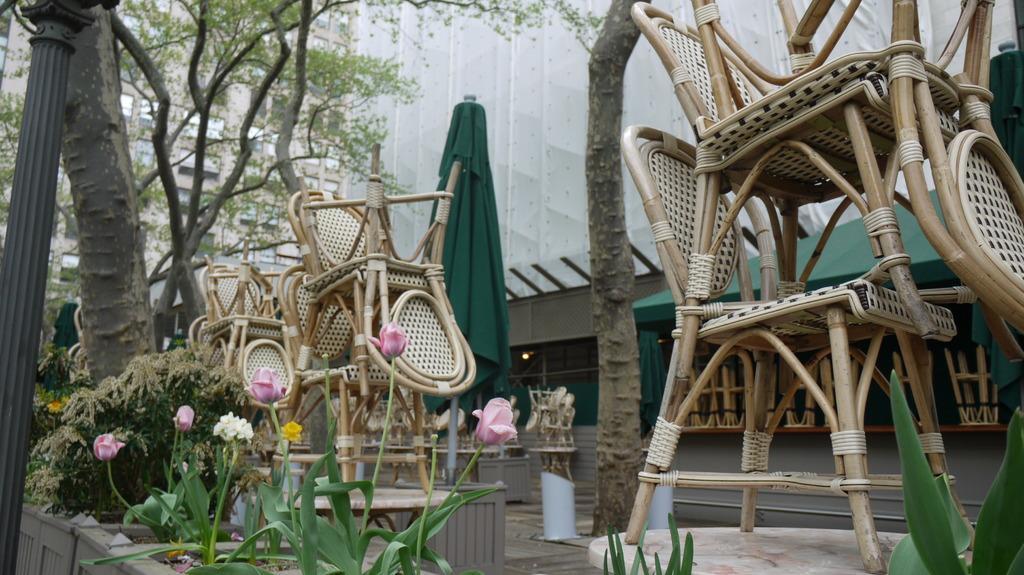In one or two sentences, can you explain what this image depicts? This the picture of the outside in which we can see the wooden chairs placed one above the other at the right side and in the left bottom there are rose plants and in the background there is a Building and some Trees and there is one Pole in the left side. 